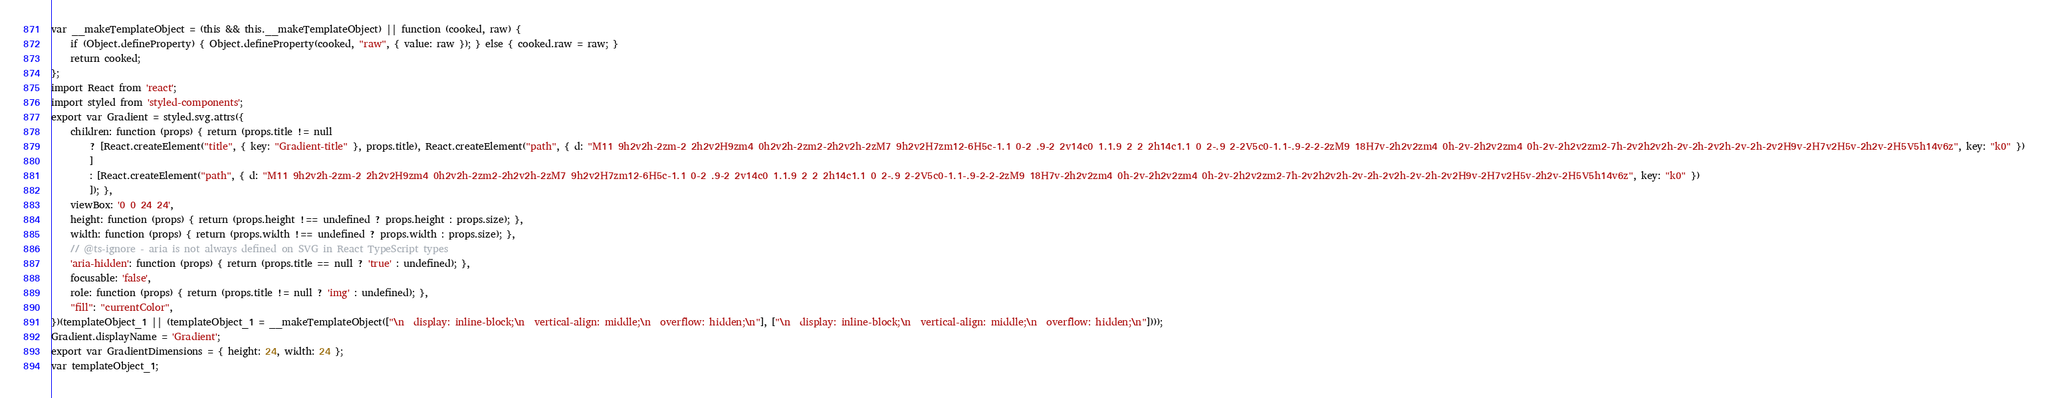Convert code to text. <code><loc_0><loc_0><loc_500><loc_500><_JavaScript_>var __makeTemplateObject = (this && this.__makeTemplateObject) || function (cooked, raw) {
    if (Object.defineProperty) { Object.defineProperty(cooked, "raw", { value: raw }); } else { cooked.raw = raw; }
    return cooked;
};
import React from 'react';
import styled from 'styled-components';
export var Gradient = styled.svg.attrs({
    children: function (props) { return (props.title != null
        ? [React.createElement("title", { key: "Gradient-title" }, props.title), React.createElement("path", { d: "M11 9h2v2h-2zm-2 2h2v2H9zm4 0h2v2h-2zm2-2h2v2h-2zM7 9h2v2H7zm12-6H5c-1.1 0-2 .9-2 2v14c0 1.1.9 2 2 2h14c1.1 0 2-.9 2-2V5c0-1.1-.9-2-2-2zM9 18H7v-2h2v2zm4 0h-2v-2h2v2zm4 0h-2v-2h2v2zm2-7h-2v2h2v2h-2v-2h-2v2h-2v-2h-2v2H9v-2H7v2H5v-2h2v-2H5V5h14v6z", key: "k0" })
        ]
        : [React.createElement("path", { d: "M11 9h2v2h-2zm-2 2h2v2H9zm4 0h2v2h-2zm2-2h2v2h-2zM7 9h2v2H7zm12-6H5c-1.1 0-2 .9-2 2v14c0 1.1.9 2 2 2h14c1.1 0 2-.9 2-2V5c0-1.1-.9-2-2-2zM9 18H7v-2h2v2zm4 0h-2v-2h2v2zm4 0h-2v-2h2v2zm2-7h-2v2h2v2h-2v-2h-2v2h-2v-2h-2v2H9v-2H7v2H5v-2h2v-2H5V5h14v6z", key: "k0" })
        ]); },
    viewBox: '0 0 24 24',
    height: function (props) { return (props.height !== undefined ? props.height : props.size); },
    width: function (props) { return (props.width !== undefined ? props.width : props.size); },
    // @ts-ignore - aria is not always defined on SVG in React TypeScript types
    'aria-hidden': function (props) { return (props.title == null ? 'true' : undefined); },
    focusable: 'false',
    role: function (props) { return (props.title != null ? 'img' : undefined); },
    "fill": "currentColor",
})(templateObject_1 || (templateObject_1 = __makeTemplateObject(["\n  display: inline-block;\n  vertical-align: middle;\n  overflow: hidden;\n"], ["\n  display: inline-block;\n  vertical-align: middle;\n  overflow: hidden;\n"])));
Gradient.displayName = 'Gradient';
export var GradientDimensions = { height: 24, width: 24 };
var templateObject_1;
</code> 